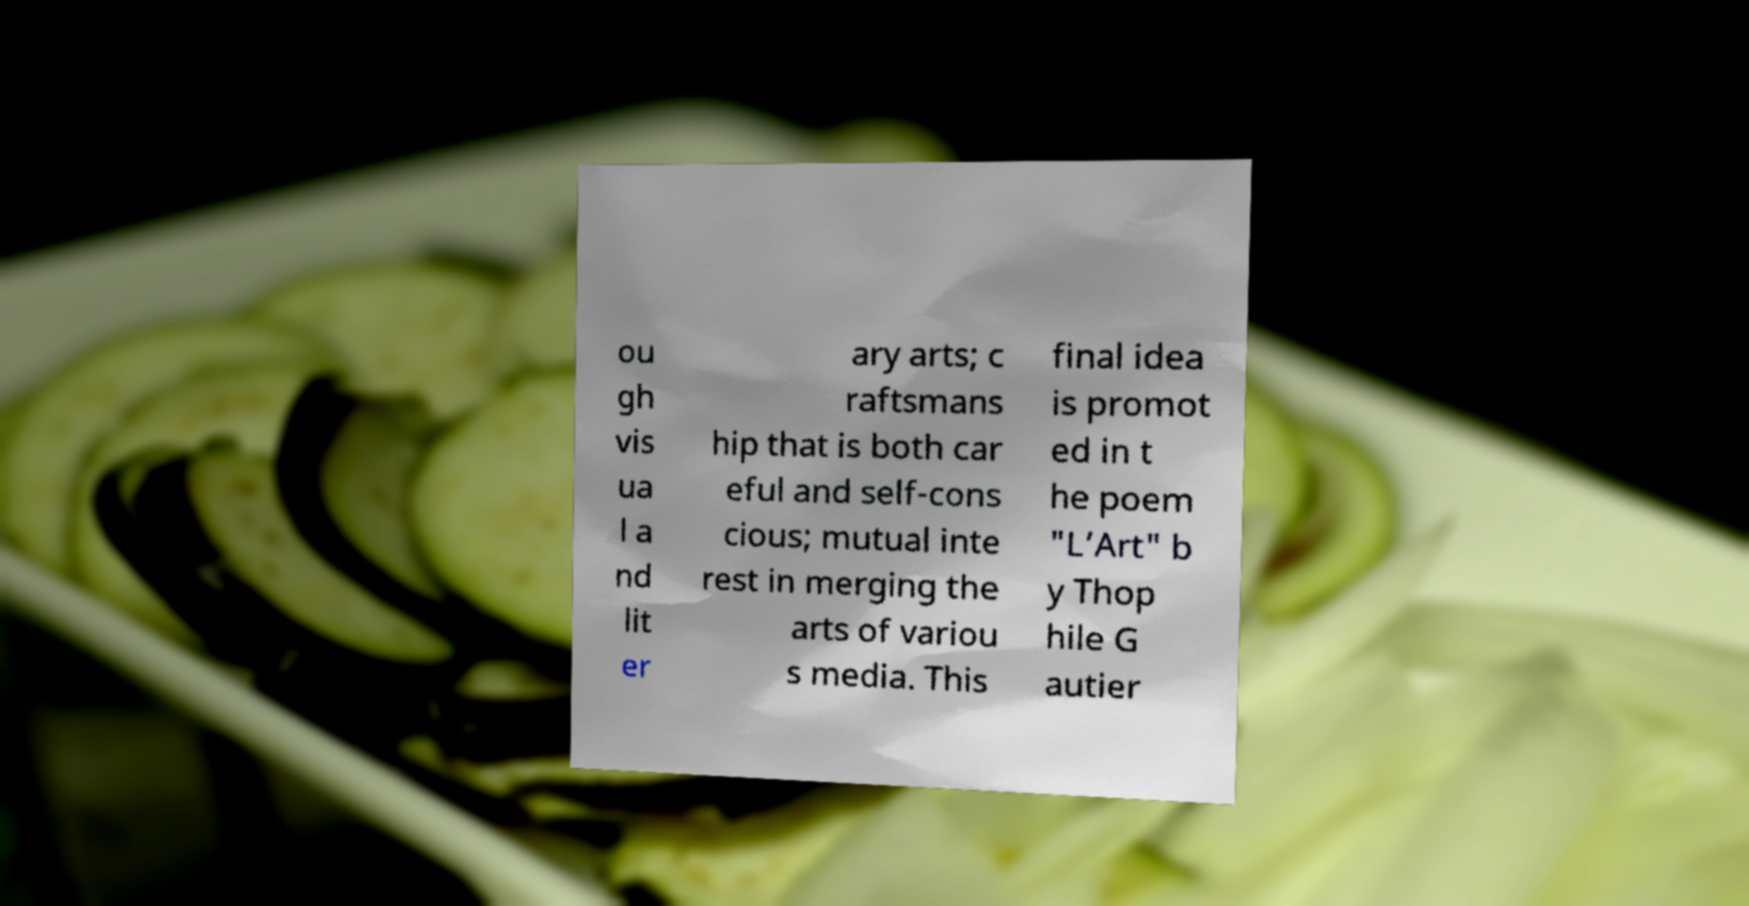I need the written content from this picture converted into text. Can you do that? ou gh vis ua l a nd lit er ary arts; c raftsmans hip that is both car eful and self-cons cious; mutual inte rest in merging the arts of variou s media. This final idea is promot ed in t he poem "L’Art" b y Thop hile G autier 